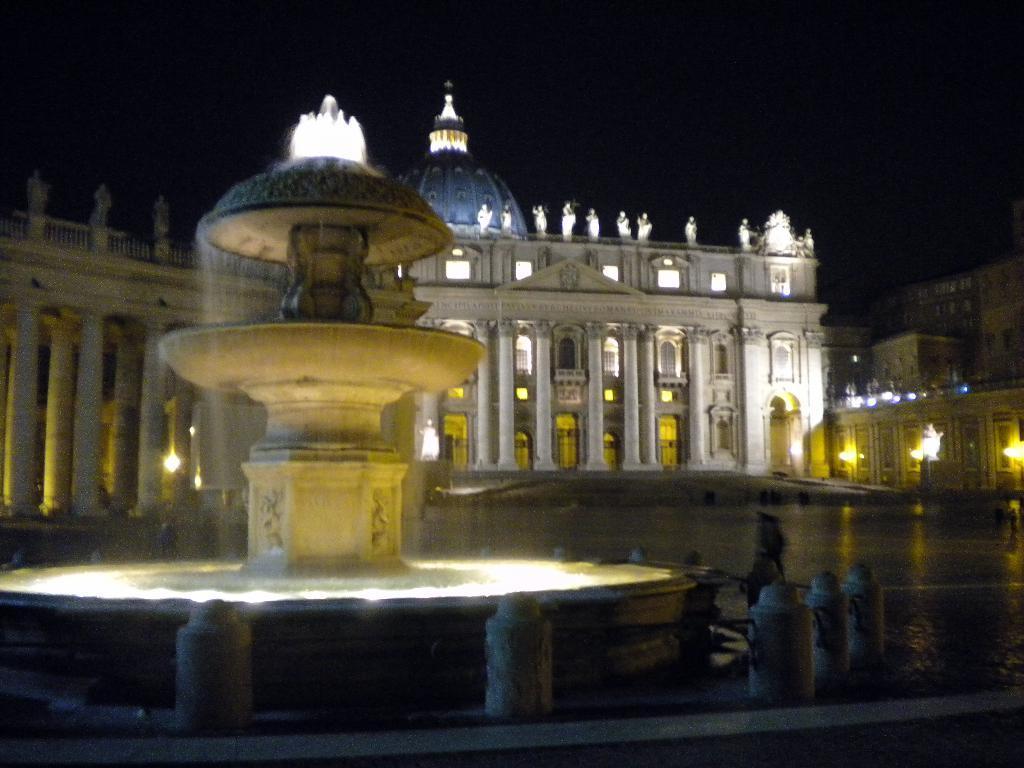Can you describe this image briefly? In this image, we can see a few buildings with sculptures. We can see a fountain. There are some poles. We can see some lights. We can see the sky and the ground. 